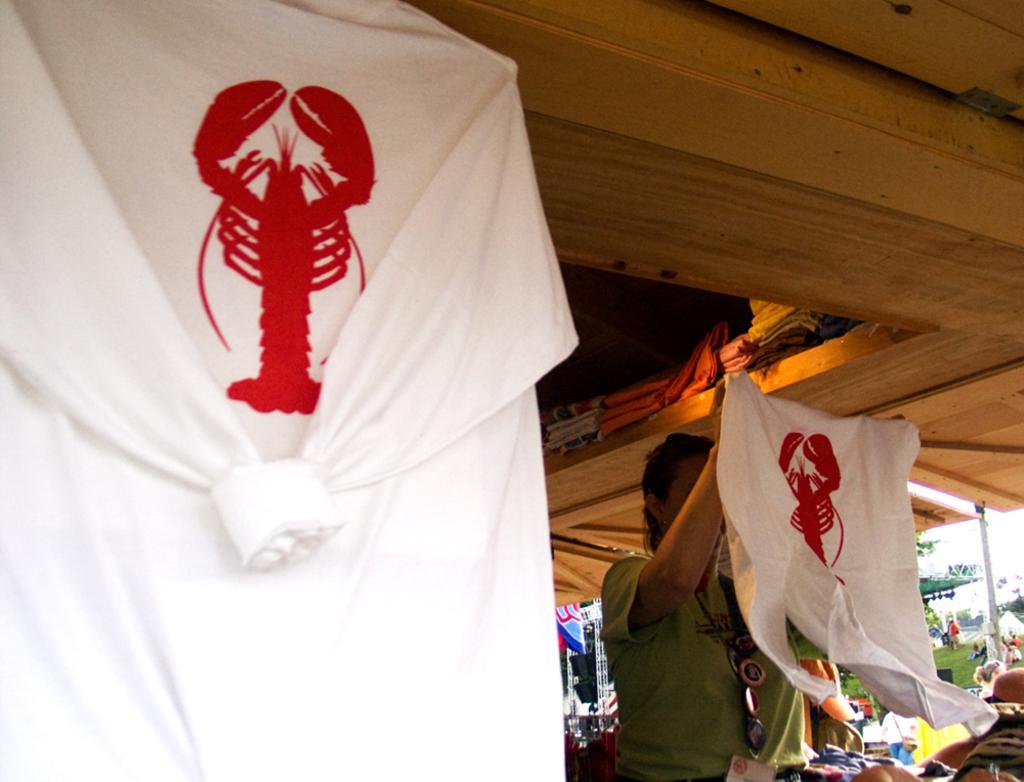Describe this image in one or two sentences. On the right side of the image we can see a person holding a t-shirt. On the left side of the image there is a t-shirt. In the background we can see light, persons, grass, tent, trees, pole and sky. 